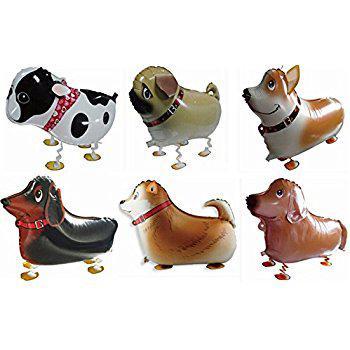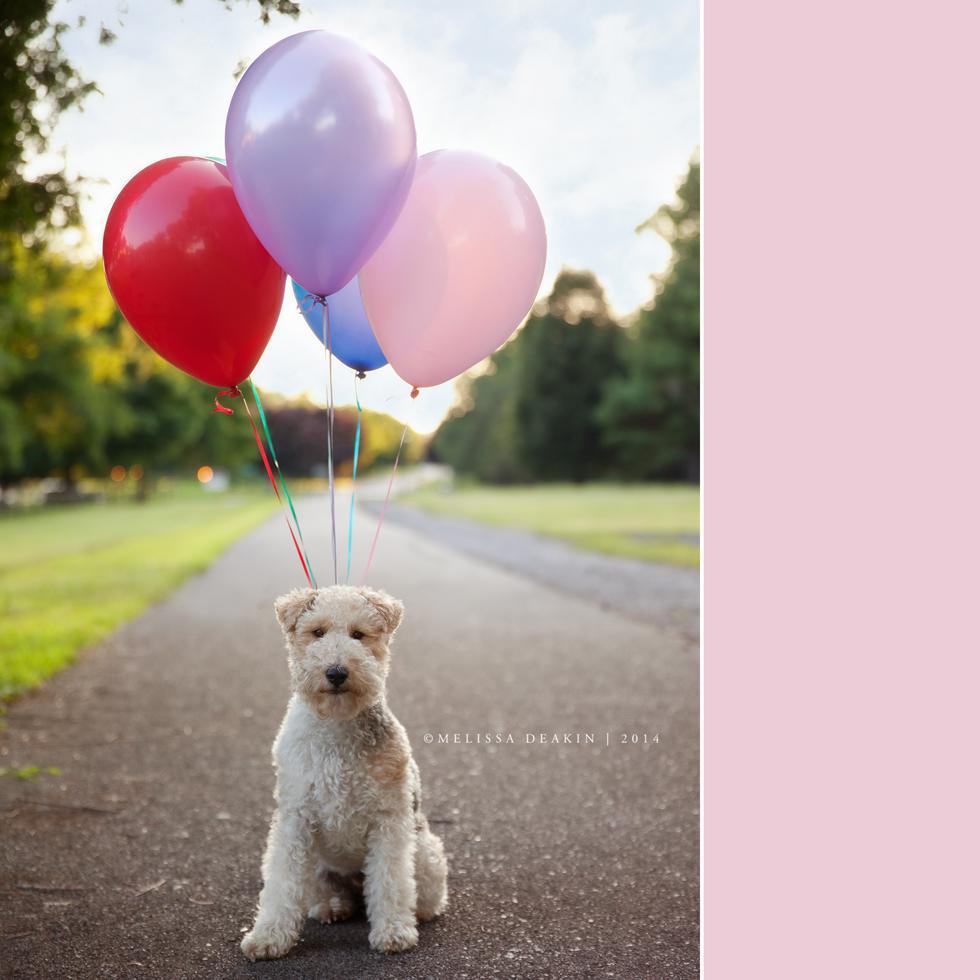The first image is the image on the left, the second image is the image on the right. Considering the images on both sides, is "There is exactly one dog in the right image." valid? Answer yes or no. Yes. The first image is the image on the left, the second image is the image on the right. Evaluate the accuracy of this statement regarding the images: "Each image includes at least one dog wearing a cone-shaped party hat with balloons floating behind it.". Is it true? Answer yes or no. No. 